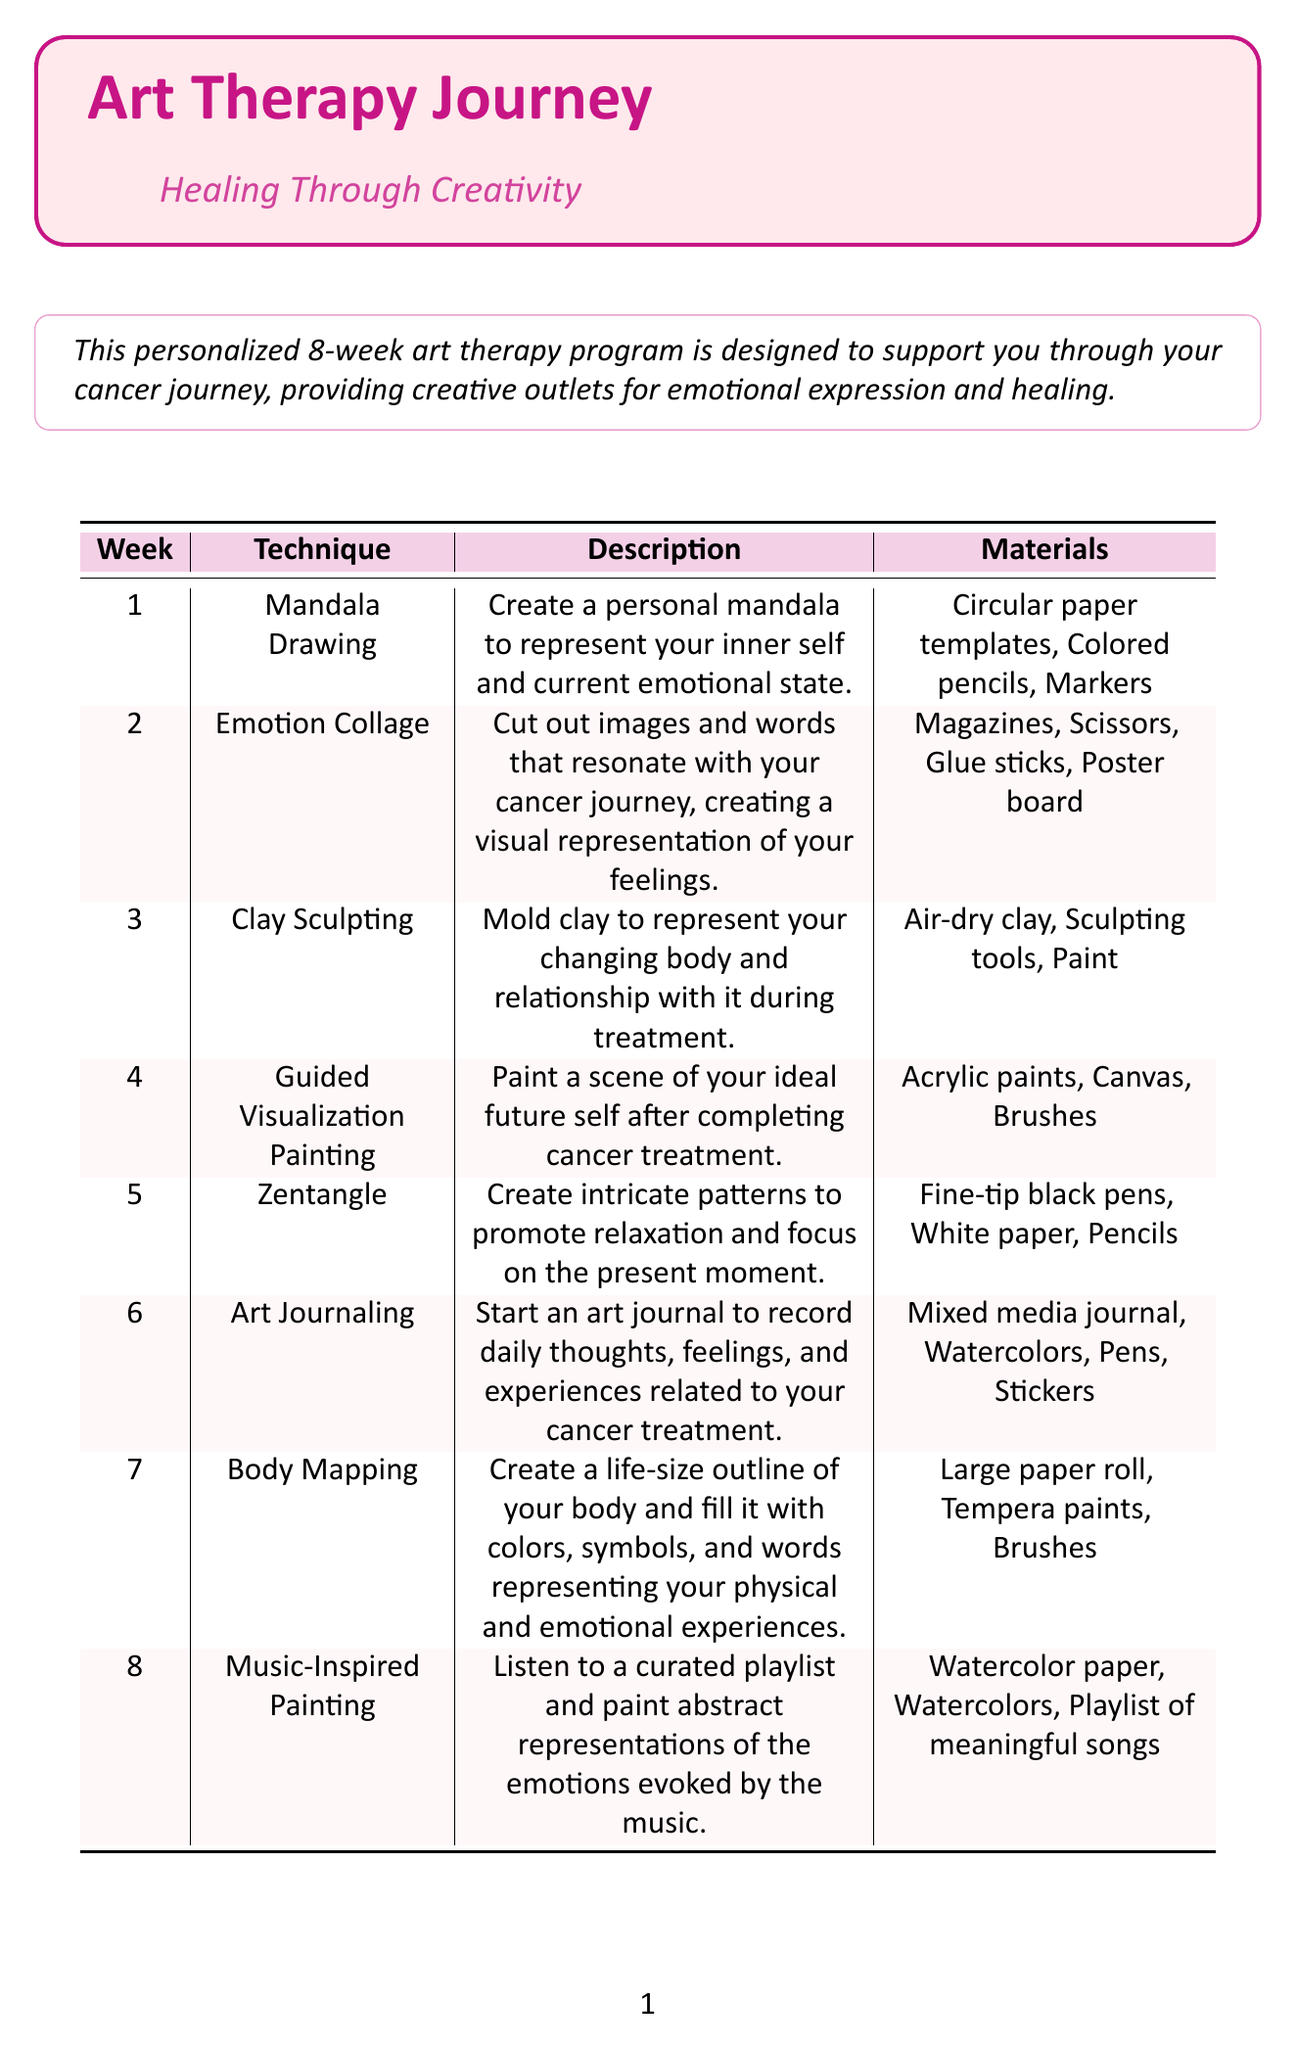what is the technique for week 1? The technique for week 1 is listed in the table under the first week section.
Answer: Mandala Drawing what materials are used in week 3? The materials for week 3 can be found in the corresponding row of the table.
Answer: Air-dry clay, Sculpting tools, Paint what is the focus of week 6? The focus of week 6 is described in the table under the respective week.
Answer: Documenting the cancer journey how many different techniques are used in the program? The number of different techniques corresponds to the number of weeks listed in the document.
Answer: 8 what is the final technique introduced in the program? The final technique is outlined in the last week of the table.
Answer: Music-Inspired Painting which session emphasizes body awareness and acceptance? The session that focuses on body awareness and acceptance is indicated in the week description.
Answer: Week 7 what type of painting is done in week 4? The type of painting for week 4 is specified in the document.
Answer: Guided Visualization Painting what are the materials for week 5? The materials for week 5 can be found in the row designated for that week.
Answer: Fine-tip black pens, White paper, Pencils 